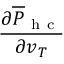<formula> <loc_0><loc_0><loc_500><loc_500>\frac { \partial \overline { P } _ { h c } } { \partial v _ { T } }</formula> 